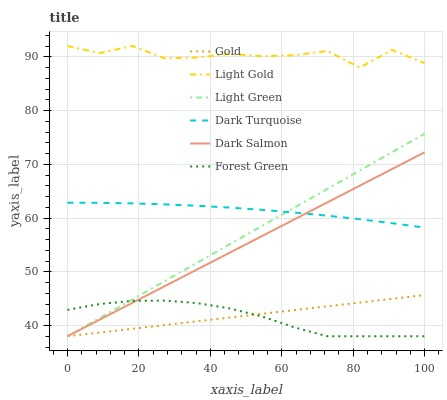Does Forest Green have the minimum area under the curve?
Answer yes or no. Yes. Does Light Gold have the maximum area under the curve?
Answer yes or no. Yes. Does Dark Turquoise have the minimum area under the curve?
Answer yes or no. No. Does Dark Turquoise have the maximum area under the curve?
Answer yes or no. No. Is Gold the smoothest?
Answer yes or no. Yes. Is Light Gold the roughest?
Answer yes or no. Yes. Is Dark Turquoise the smoothest?
Answer yes or no. No. Is Dark Turquoise the roughest?
Answer yes or no. No. Does Gold have the lowest value?
Answer yes or no. Yes. Does Dark Turquoise have the lowest value?
Answer yes or no. No. Does Light Gold have the highest value?
Answer yes or no. Yes. Does Dark Turquoise have the highest value?
Answer yes or no. No. Is Forest Green less than Light Gold?
Answer yes or no. Yes. Is Light Gold greater than Light Green?
Answer yes or no. Yes. Does Light Green intersect Forest Green?
Answer yes or no. Yes. Is Light Green less than Forest Green?
Answer yes or no. No. Is Light Green greater than Forest Green?
Answer yes or no. No. Does Forest Green intersect Light Gold?
Answer yes or no. No. 